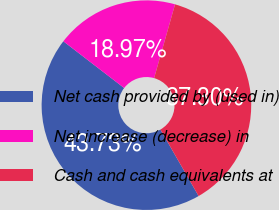<chart> <loc_0><loc_0><loc_500><loc_500><pie_chart><fcel>Net cash provided by (used in)<fcel>Net increase (decrease) in<fcel>Cash and cash equivalents at<nl><fcel>43.73%<fcel>18.97%<fcel>37.3%<nl></chart> 